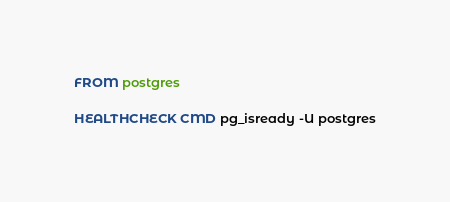<code> <loc_0><loc_0><loc_500><loc_500><_Dockerfile_>FROM postgres

HEALTHCHECK CMD pg_isready -U postgres</code> 